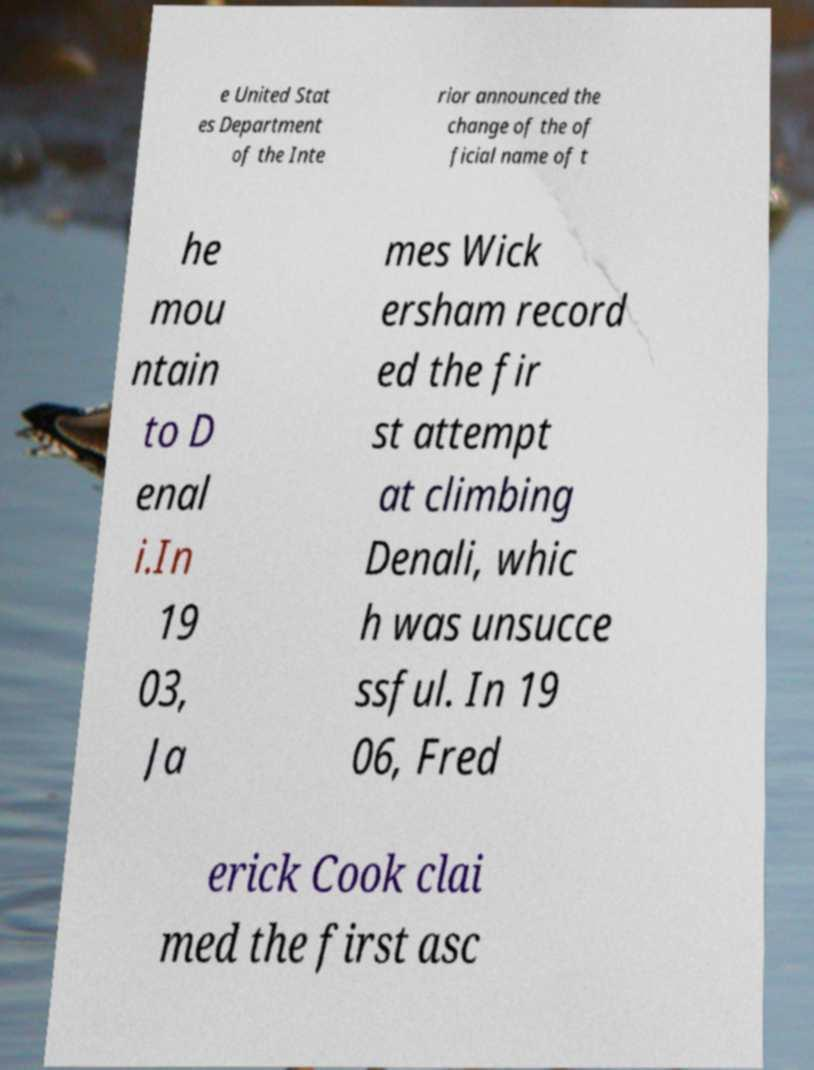Can you accurately transcribe the text from the provided image for me? e United Stat es Department of the Inte rior announced the change of the of ficial name of t he mou ntain to D enal i.In 19 03, Ja mes Wick ersham record ed the fir st attempt at climbing Denali, whic h was unsucce ssful. In 19 06, Fred erick Cook clai med the first asc 